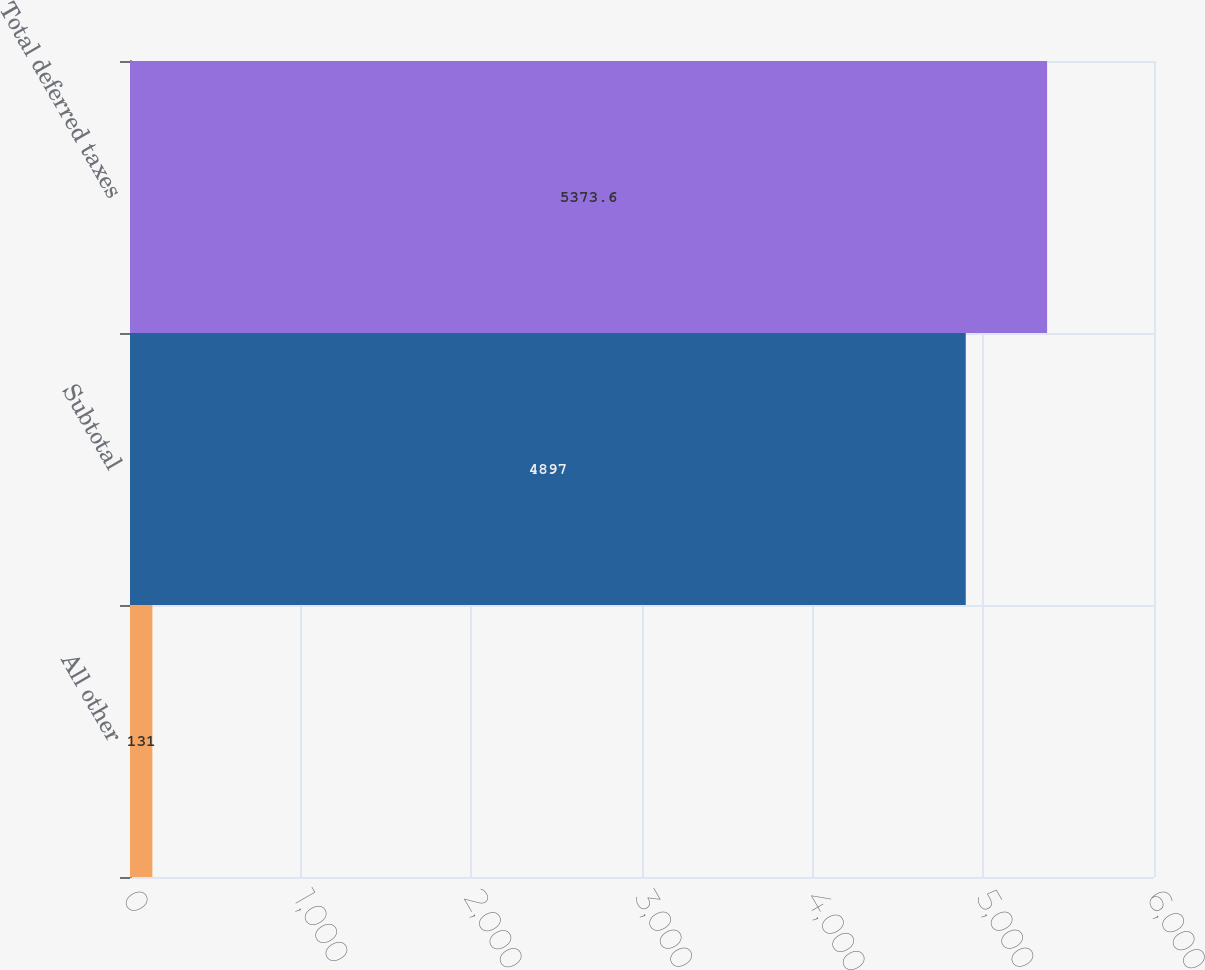Convert chart. <chart><loc_0><loc_0><loc_500><loc_500><bar_chart><fcel>All other<fcel>Subtotal<fcel>Total deferred taxes<nl><fcel>131<fcel>4897<fcel>5373.6<nl></chart> 